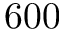Convert formula to latex. <formula><loc_0><loc_0><loc_500><loc_500>6 0 0</formula> 